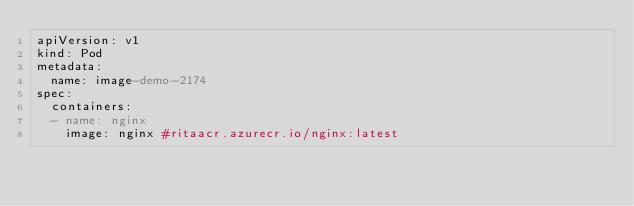<code> <loc_0><loc_0><loc_500><loc_500><_YAML_>apiVersion: v1
kind: Pod
metadata:
  name: image-demo-2174
spec:
  containers:
  - name: nginx
    image: nginx #ritaacr.azurecr.io/nginx:latest</code> 